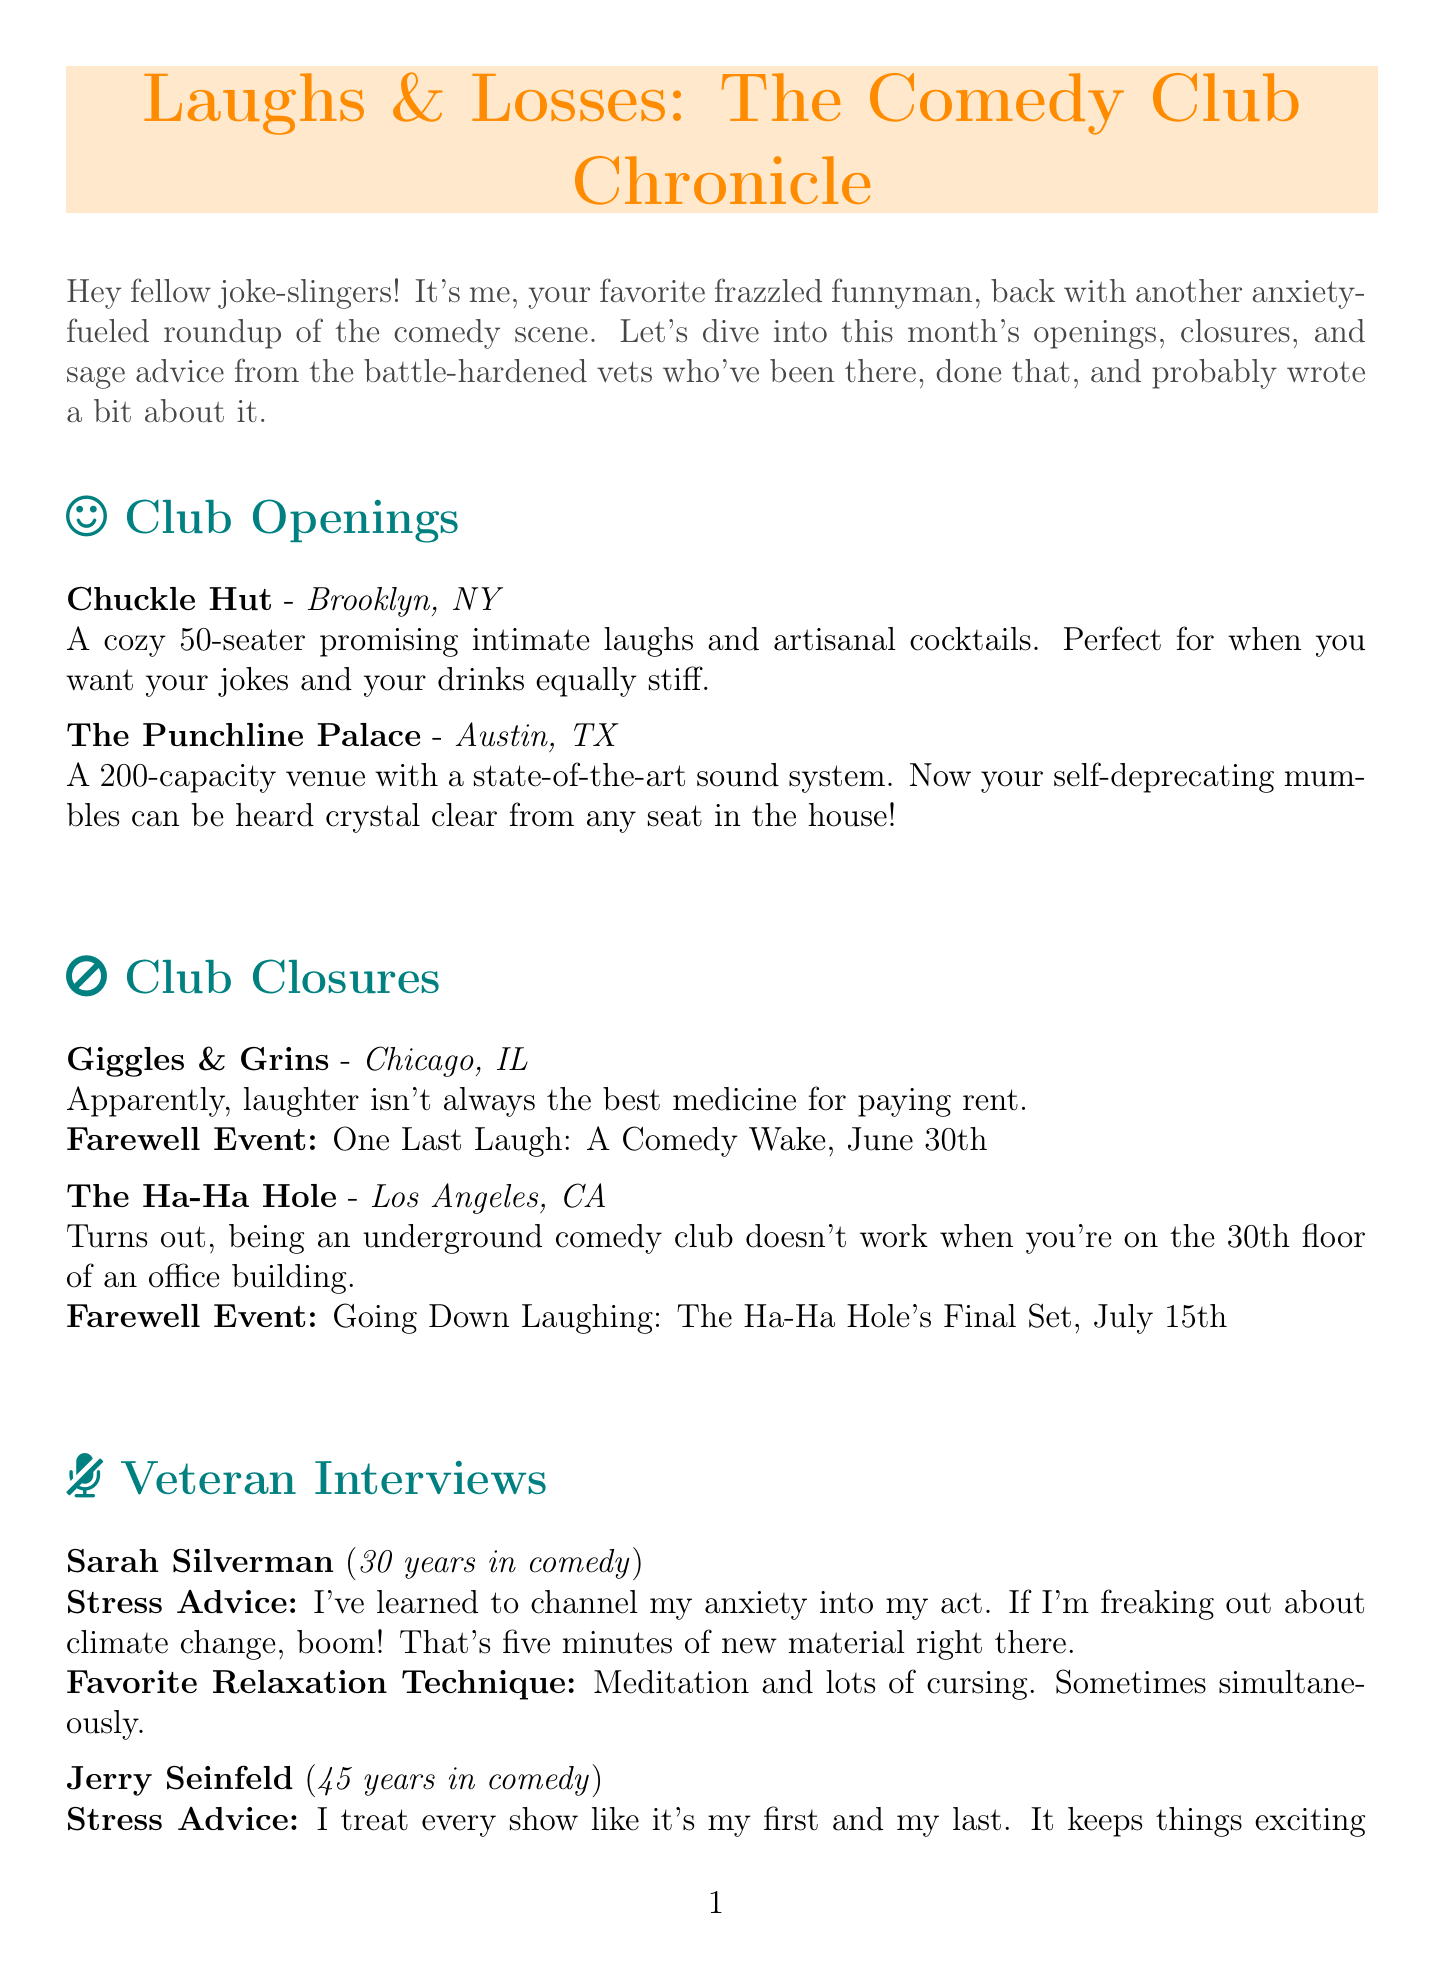What is the newsletter title? The title of the newsletter is explicitly stated at the beginning of the document.
Answer: Laughs & Losses: The Comedy Club Chronicle Where is Chuckle Hut located? The document provides specific locations for the new comedy clubs within the openings section.
Answer: Brooklyn, NY What is the reason for Giggles & Grins' closure? The document mentions the reasons for each club's closure, providing insight into the challenges faced by comedy venues.
Answer: Apparently, laughter isn't always the best medicine for paying rent Who is featured in the first veteran interview? The document lists veteran comedians and their features, including the order in which they are presented.
Answer: Sarah Silverman What is the date of the Laugh Your Stress Away Workshop? The workshop details, including date and location, are specified under upcoming events in the document.
Answer: July 10th What is one of Dave Chappelle's relaxation techniques? The document states each veteran's favorite relaxation technique, highlighting their personal approaches.
Answer: Long walks in the Ohio countryside How many years has Jerry Seinfeld been in comedy? The years of experience for each veteran comedian are noted in the interviews section of the document.
Answer: 45 What unique feature does The Punchline Palace offer? The document describes the special features or amenities of the comedy clubs that are newly opened.
Answer: State-of-the-art sound system 